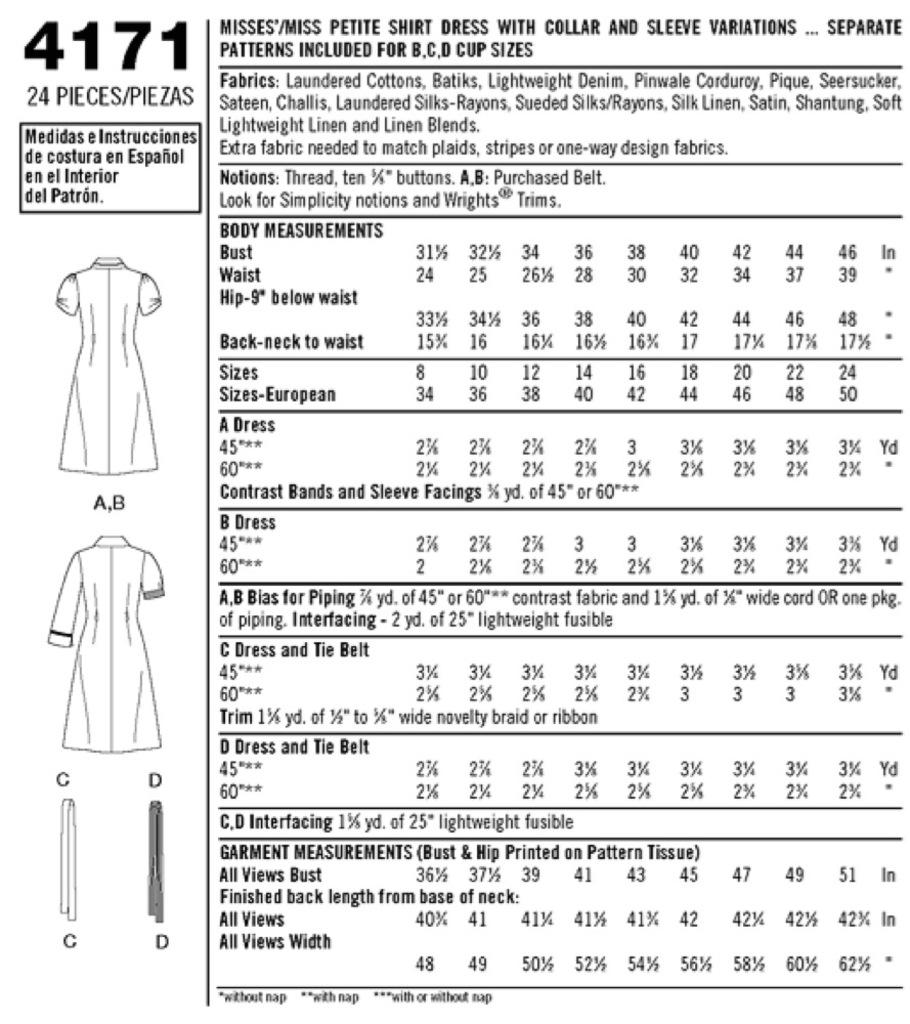What is the main subject of the chart in the image? The chart is about ladies' dresses. What type of information is presented on the chart? There is text written in words and numbers on the chart. How many boats are mentioned in the chart? There are no boats mentioned in the chart; it is about ladies' dresses. What type of punishment is associated with the chart? There is no punishment associated with the chart; it is a chart about ladies' dresses. 